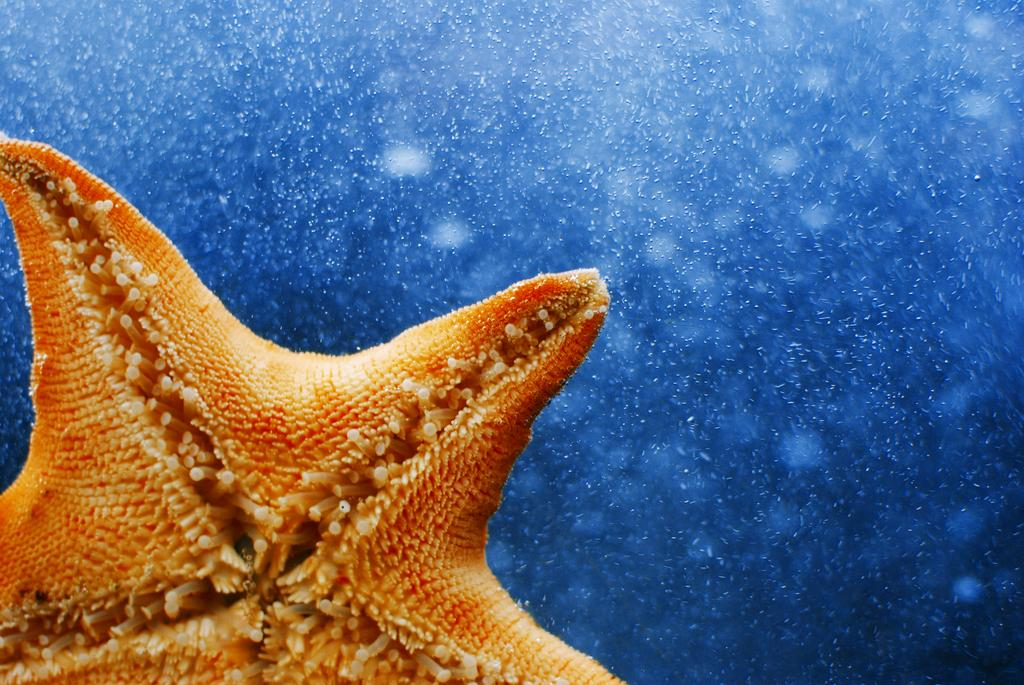What type of picture is the image? The image is a zoomed-in picture. What can be seen in the foreground of the image? There is a marine creature in the foreground, which appears to be a starfish. What is visible in the background of the image? There is a water body visible in the background. What are the tiny particles in the background? The tiny particles in the background could be sand or other small particles found in a water body. What government policy is being discussed in the image? There is no discussion or indication of any government policy in the image; it is a picture of a starfish in a water body. 